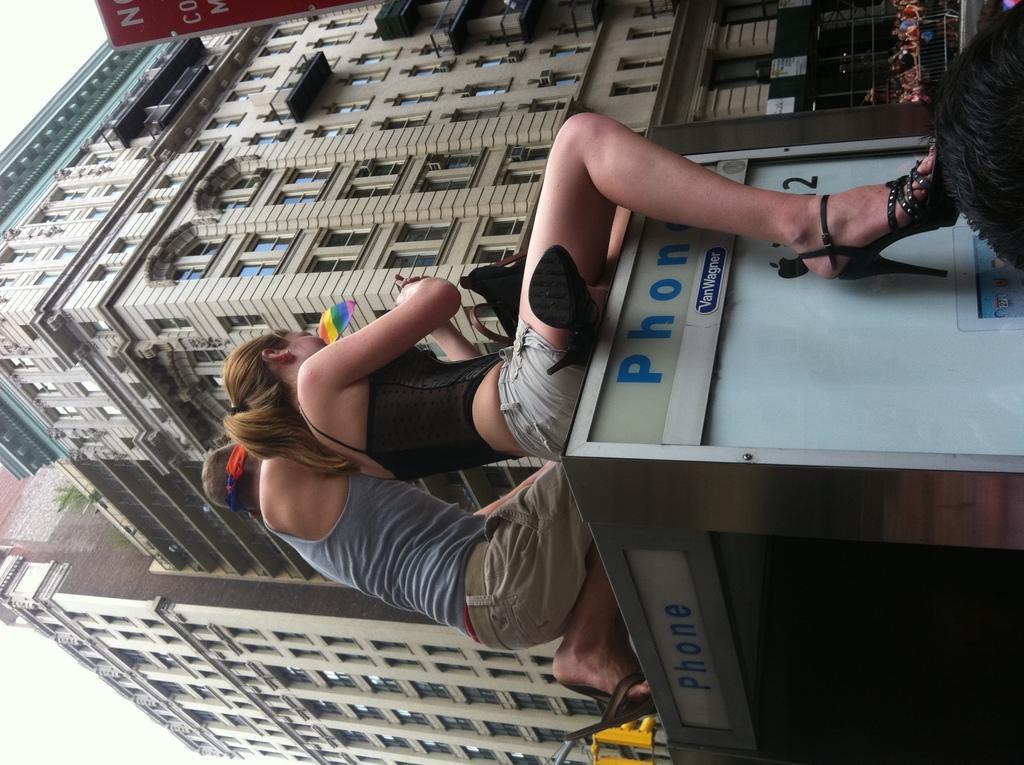How would you summarize this image in a sentence or two? In this image we can see a man and a woman sitting on a table containing a bag and some text on it. On the backside we can see a group of people sitting, a building with windows, some plants, a signboard and the sky which looks cloudy. 